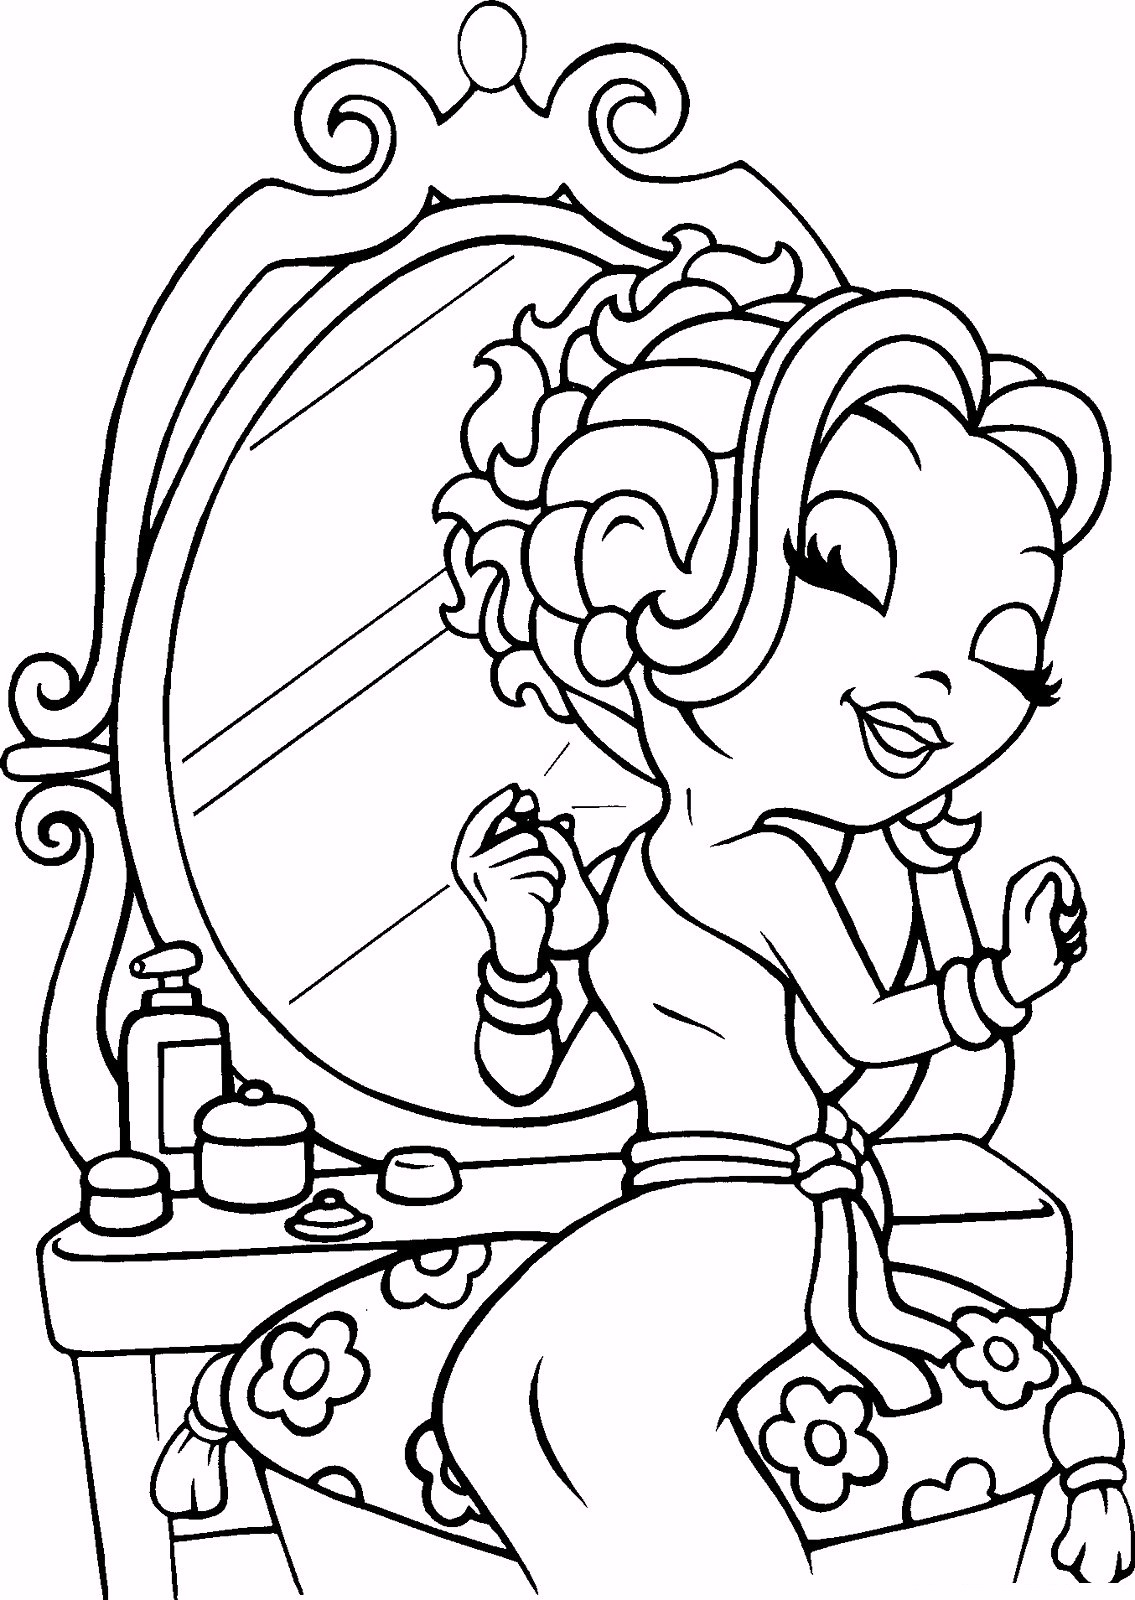Imagine this is a scene from a story about a princess preparing for a grand ball. What might be the significance of this moment, and how would you describe the atmosphere? In the story, this moment might represent the princess preparing herself for a grand ball, a significant evening where she will make a grand entrance and socialize with other royals. The atmosphere is one of anticipation and excitement, filled with the soft glow of candlelight reflecting off the ornate mirror and gentle music playing in the background. The smell of lavender and roses imbues the air as the princess meticulously attends to her nails, ensuring every detail is perfect. Each product on the table symbolizes her careful preparations for the night ahead, where she hopes to make a lasting impression. The scene reflects her dedication to presenting herself with grace and elegance, highlighting the importance of self-care and personal presentation in the life of the royal. 